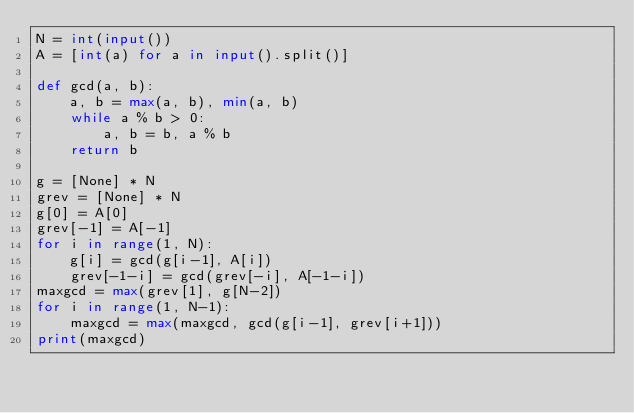<code> <loc_0><loc_0><loc_500><loc_500><_Python_>N = int(input())
A = [int(a) for a in input().split()]

def gcd(a, b):
    a, b = max(a, b), min(a, b)
    while a % b > 0:
        a, b = b, a % b
    return b

g = [None] * N
grev = [None] * N
g[0] = A[0]
grev[-1] = A[-1]
for i in range(1, N):
    g[i] = gcd(g[i-1], A[i])
    grev[-1-i] = gcd(grev[-i], A[-1-i])
maxgcd = max(grev[1], g[N-2])
for i in range(1, N-1):
    maxgcd = max(maxgcd, gcd(g[i-1], grev[i+1]))
print(maxgcd)</code> 